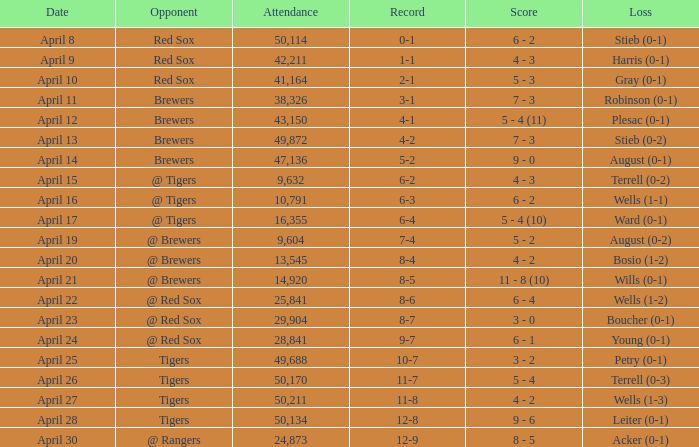In which loss does the attendance surpass 49,688 and the record stands at 11-8? Wells (1-3). 